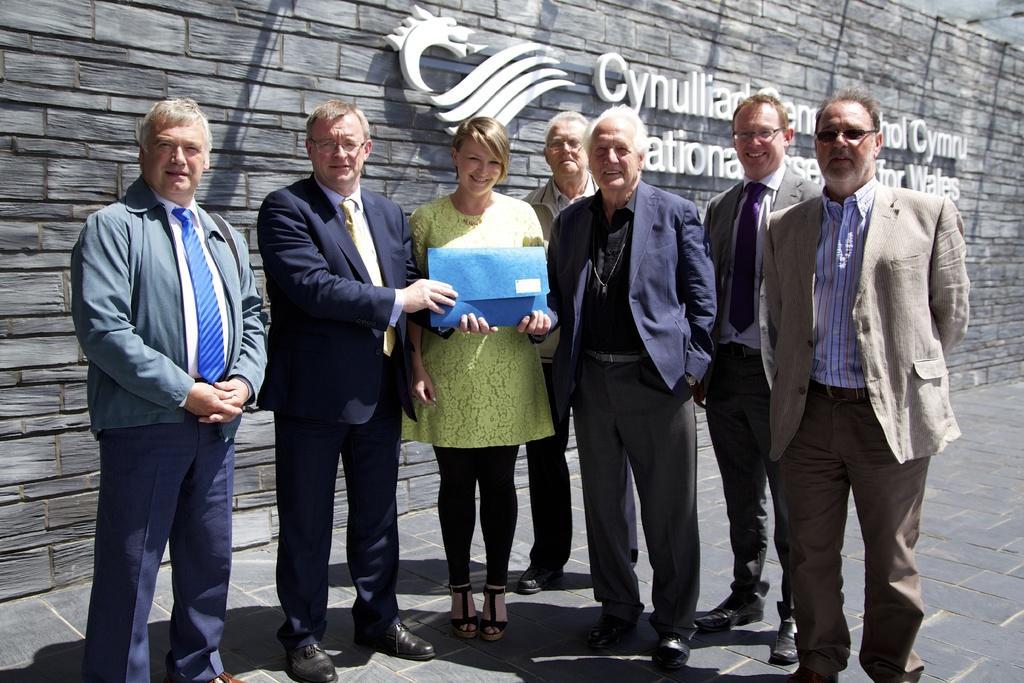Please provide a concise description of this image. In the picture we can see some men and woman are standing, one man is giving something to the woman, and men are all in the blazers, ties and shirts and woman is in the green dress and in the background we can see the wall with something written on it. 